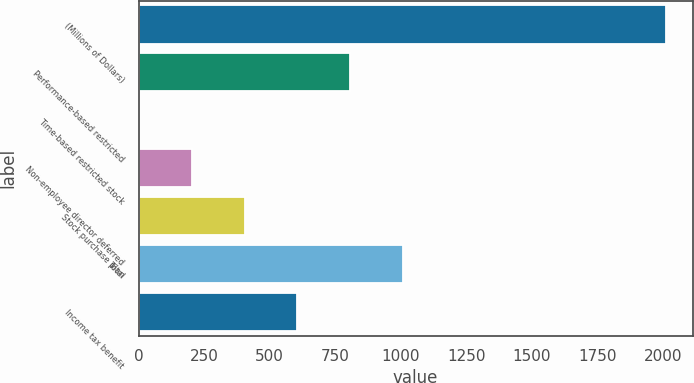Convert chart. <chart><loc_0><loc_0><loc_500><loc_500><bar_chart><fcel>(Millions of Dollars)<fcel>Performance-based restricted<fcel>Time-based restricted stock<fcel>Non-employee director deferred<fcel>Stock purchase plan<fcel>Total<fcel>Income tax benefit<nl><fcel>2013<fcel>806.4<fcel>2<fcel>203.1<fcel>404.2<fcel>1007.5<fcel>605.3<nl></chart> 